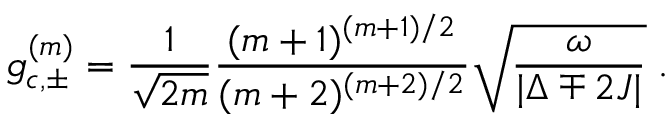<formula> <loc_0><loc_0><loc_500><loc_500>g _ { c , \pm } ^ { ( m ) } = \frac { 1 } { \sqrt { 2 m } } \frac { ( m + 1 ) ^ { ( m + 1 ) / 2 } } { ( m + 2 ) ^ { ( m + 2 ) / 2 } } \sqrt { \frac { \omega } { | { \Delta \mp 2 J } | } } \, .</formula> 